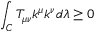<formula> <loc_0><loc_0><loc_500><loc_500>\int _ { C } T _ { \mu \nu } k ^ { \mu } k ^ { \nu } d \lambda \geq 0</formula> 